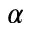Convert formula to latex. <formula><loc_0><loc_0><loc_500><loc_500>\alpha</formula> 